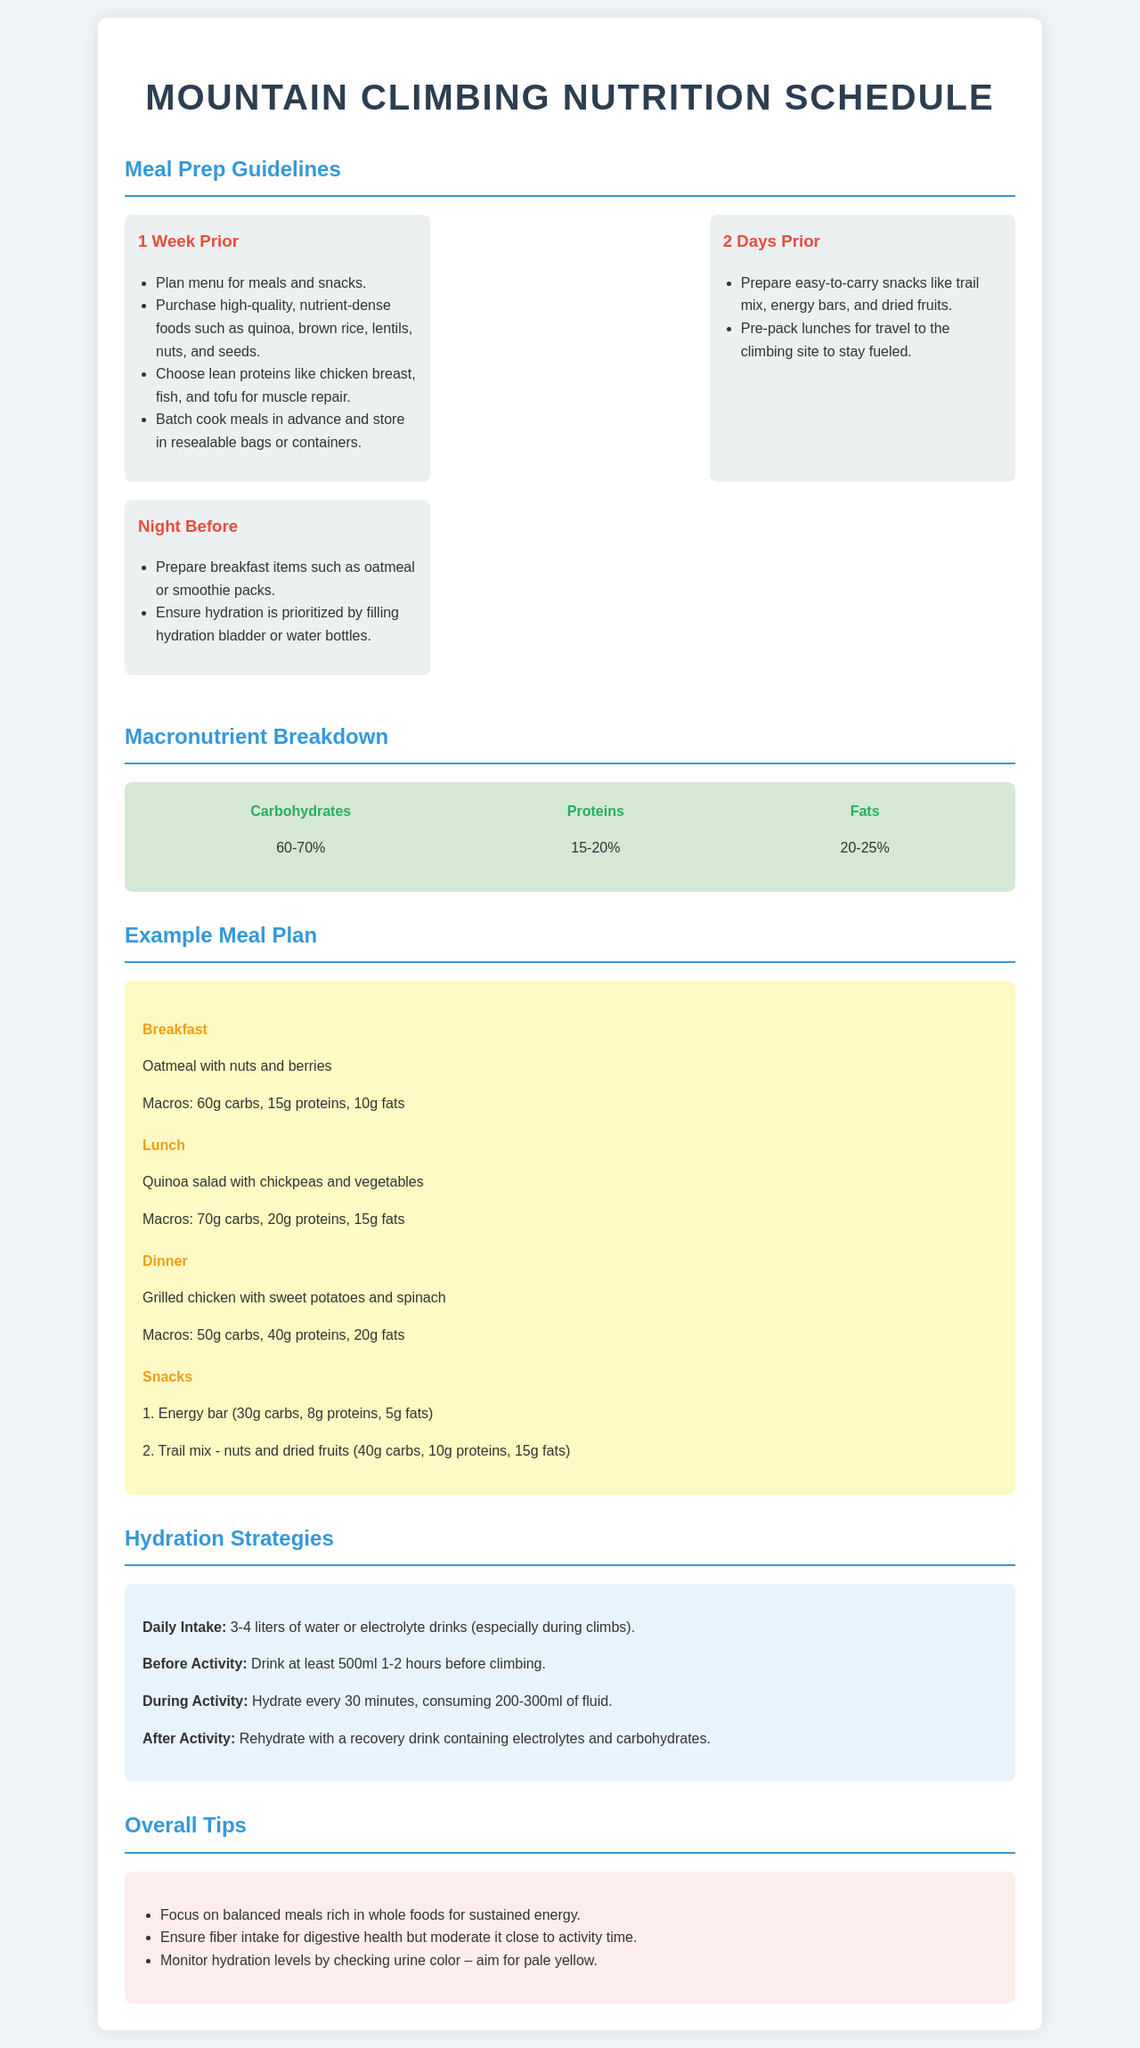what percentage of carbohydrates is recommended? The recommended percentage of carbohydrates is indicated in the macronutrient breakdown section of the document.
Answer: 60-70% what should be prepared two days prior to the climb? The document specifies that easy-to-carry snacks and pre-packed lunches should be prepared two days before the climb.
Answer: Snacks and lunches how much water should be consumed before activity? The hydration strategies section states the volume of water recommended before climbing.
Answer: 500ml what is the macronutrient breakdown for proteins? The document specifies the percentage of proteins in the overall macronutrient breakdown.
Answer: 15-20% what meal includes grilled chicken? The example meal plan provides a specific meal where grilled chicken is included.
Answer: Dinner 